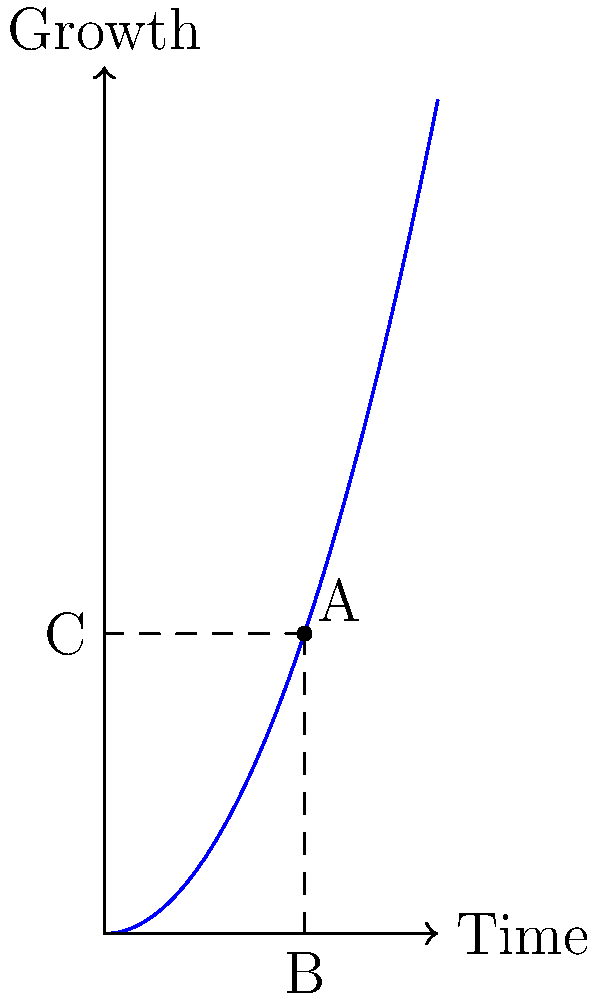In the graph representing your personal growth trajectory, point A represents your current position after 3 years of consistent effort. If the curve follows the function $f(x) = 0.5x^2$, where x is time in years, what is the angle (in degrees) between the x-axis and the line connecting the origin to point A? Round your answer to the nearest whole number. To find the angle between the x-axis and the line connecting the origin to point A, we need to follow these steps:

1) First, let's identify the coordinates of point A:
   x-coordinate = 3 years
   y-coordinate = $f(3) = 0.5(3^2) = 4.5$

   So, A is at (3, 4.5)

2) Now, we can treat this as a right-angled triangle, where:
   - The base (along the x-axis) is 3
   - The height (along the y-axis) is 4.5

3) To find the angle, we can use the arctangent function:
   $\theta = \arctan(\frac{\text{opposite}}{\text{adjacent}}) = \arctan(\frac{4.5}{3})$

4) Calculate this:
   $\theta = \arctan(1.5) \approx 0.982$ radians

5) Convert radians to degrees:
   $\theta \text{ in degrees} = 0.982 \times \frac{180}{\pi} \approx 56.31°$

6) Rounding to the nearest whole number:
   $56.31° \approx 56°$
Answer: 56° 